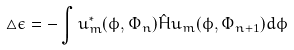Convert formula to latex. <formula><loc_0><loc_0><loc_500><loc_500>\triangle \epsilon = - \int u ^ { * } _ { m } ( \phi , \Phi _ { n } ) \hat { H } u _ { m } ( \phi , \Phi _ { n + 1 } ) d \phi</formula> 